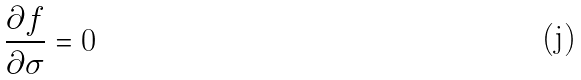<formula> <loc_0><loc_0><loc_500><loc_500>\frac { \partial f } { \partial \sigma } = 0</formula> 